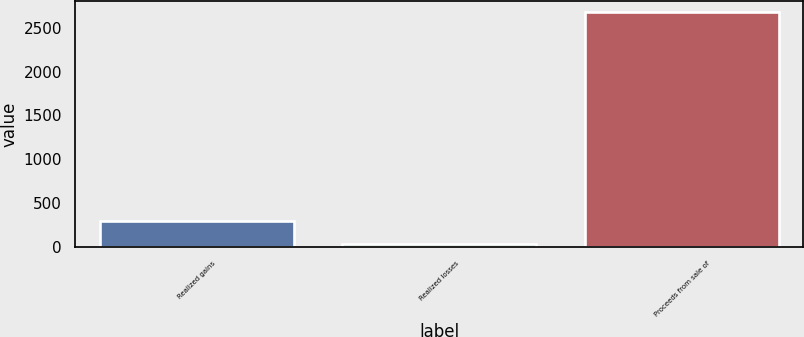<chart> <loc_0><loc_0><loc_500><loc_500><bar_chart><fcel>Realized gains<fcel>Realized losses<fcel>Proceeds from sale of<nl><fcel>298.8<fcel>35<fcel>2673<nl></chart> 